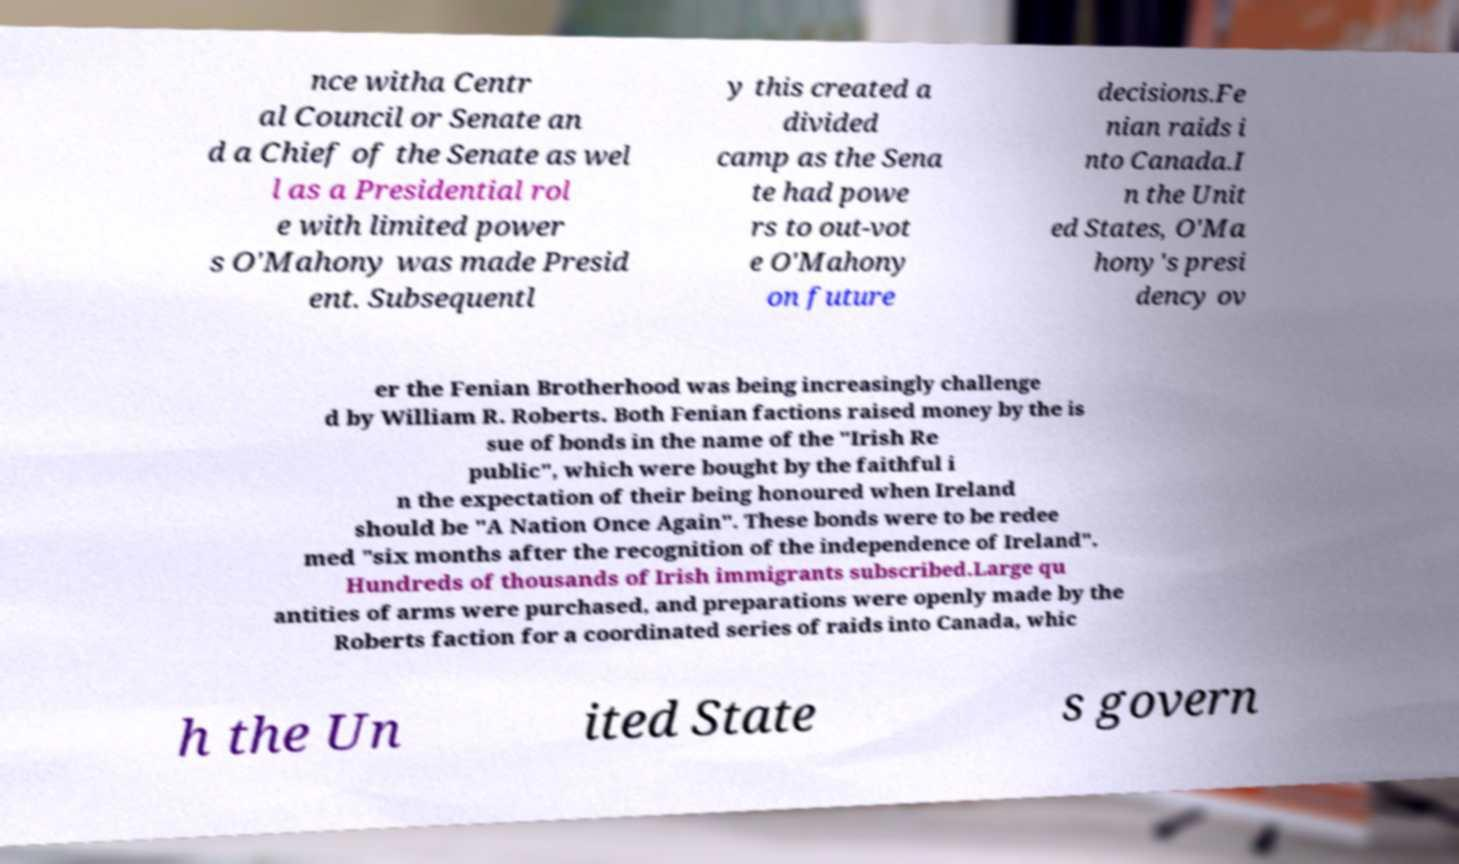Please read and relay the text visible in this image. What does it say? nce witha Centr al Council or Senate an d a Chief of the Senate as wel l as a Presidential rol e with limited power s O'Mahony was made Presid ent. Subsequentl y this created a divided camp as the Sena te had powe rs to out-vot e O'Mahony on future decisions.Fe nian raids i nto Canada.I n the Unit ed States, O'Ma hony's presi dency ov er the Fenian Brotherhood was being increasingly challenge d by William R. Roberts. Both Fenian factions raised money by the is sue of bonds in the name of the "Irish Re public", which were bought by the faithful i n the expectation of their being honoured when Ireland should be "A Nation Once Again". These bonds were to be redee med "six months after the recognition of the independence of Ireland". Hundreds of thousands of Irish immigrants subscribed.Large qu antities of arms were purchased, and preparations were openly made by the Roberts faction for a coordinated series of raids into Canada, whic h the Un ited State s govern 